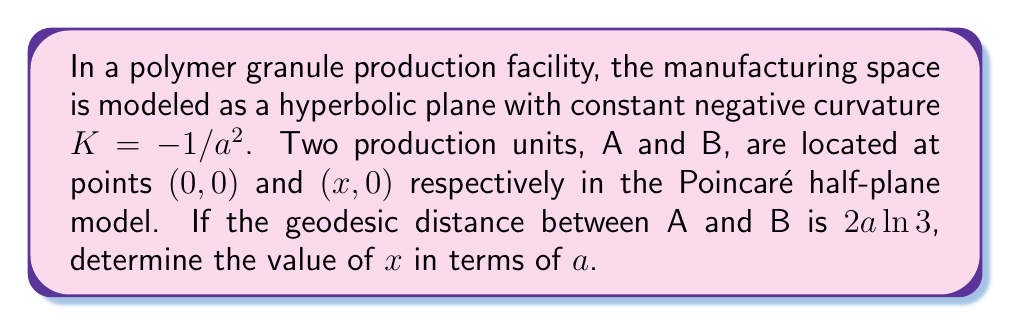Could you help me with this problem? Let's approach this step-by-step:

1) In the Poincaré half-plane model of hyperbolic geometry, the geodesic between two points on the x-axis is a semicircle centered on the x-axis.

2) The geodesic distance $d$ between two points $(x_1, y_1)$ and $(x_2, y_2)$ in this model is given by:

   $$d = a \cdot \text{arcosh}\left(1 + \frac{(x_2 - x_1)^2 + (y_2 - y_1)^2}{2y_1y_2}\right)$$

3) In our case, $y_1 = y_2 = 1$ (as both points are on the x-axis), $x_1 = 0$, and $x_2 = x$. Also, we're given that $d = 2a \ln 3$. Substituting these into the formula:

   $$2a \ln 3 = a \cdot \text{arcosh}\left(1 + \frac{x^2}{2}\right)$$

4) Simplifying:

   $$2 \ln 3 = \text{arcosh}\left(1 + \frac{x^2}{2}\right)$$

5) Taking $\cosh$ of both sides:

   $$\cosh(2 \ln 3) = 1 + \frac{x^2}{2}$$

6) Using the identity $\cosh(2\ln 3) = \frac{e^{2\ln 3} + e^{-2\ln 3}}{2} = \frac{9 + 1/9}{2} = \frac{82}{18}$:

   $$\frac{82}{18} = 1 + \frac{x^2}{2}$$

7) Solving for $x$:

   $$\frac{x^2}{2} = \frac{82}{18} - 1 = \frac{32}{9}$$
   $$x^2 = \frac{64}{9}$$
   $$x = \frac{8}{3}$$

Therefore, the x-coordinate of point B is $\frac{8a}{3}$.
Answer: $x = \frac{8a}{3}$ 